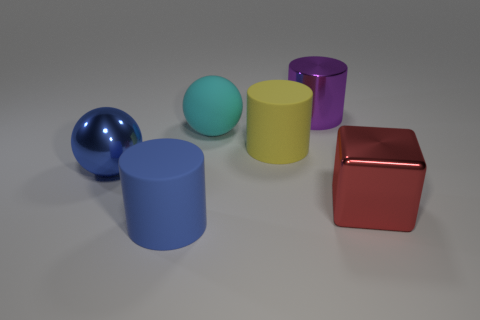What size is the rubber sphere on the left side of the red metallic cube to the right of the big cyan ball?
Your response must be concise. Large. Are there more yellow rubber blocks than big red shiny cubes?
Ensure brevity in your answer.  No. Is the number of blue rubber things behind the large cyan matte sphere greater than the number of big matte cylinders that are in front of the yellow matte object?
Your answer should be compact. No. How big is the cylinder that is both behind the blue shiny sphere and in front of the purple shiny object?
Keep it short and to the point. Large. How many other cylinders are the same size as the purple cylinder?
Your answer should be very brief. 2. What is the material of the large cylinder that is the same color as the large shiny ball?
Keep it short and to the point. Rubber. There is a metal object that is behind the blue metal object; is it the same shape as the big yellow thing?
Your response must be concise. Yes. Are there fewer cyan objects that are left of the matte sphere than red objects?
Your answer should be very brief. Yes. Are there any big matte cylinders that have the same color as the cube?
Ensure brevity in your answer.  No. Do the red thing and the large blue object in front of the blue metallic object have the same shape?
Provide a short and direct response. No. 